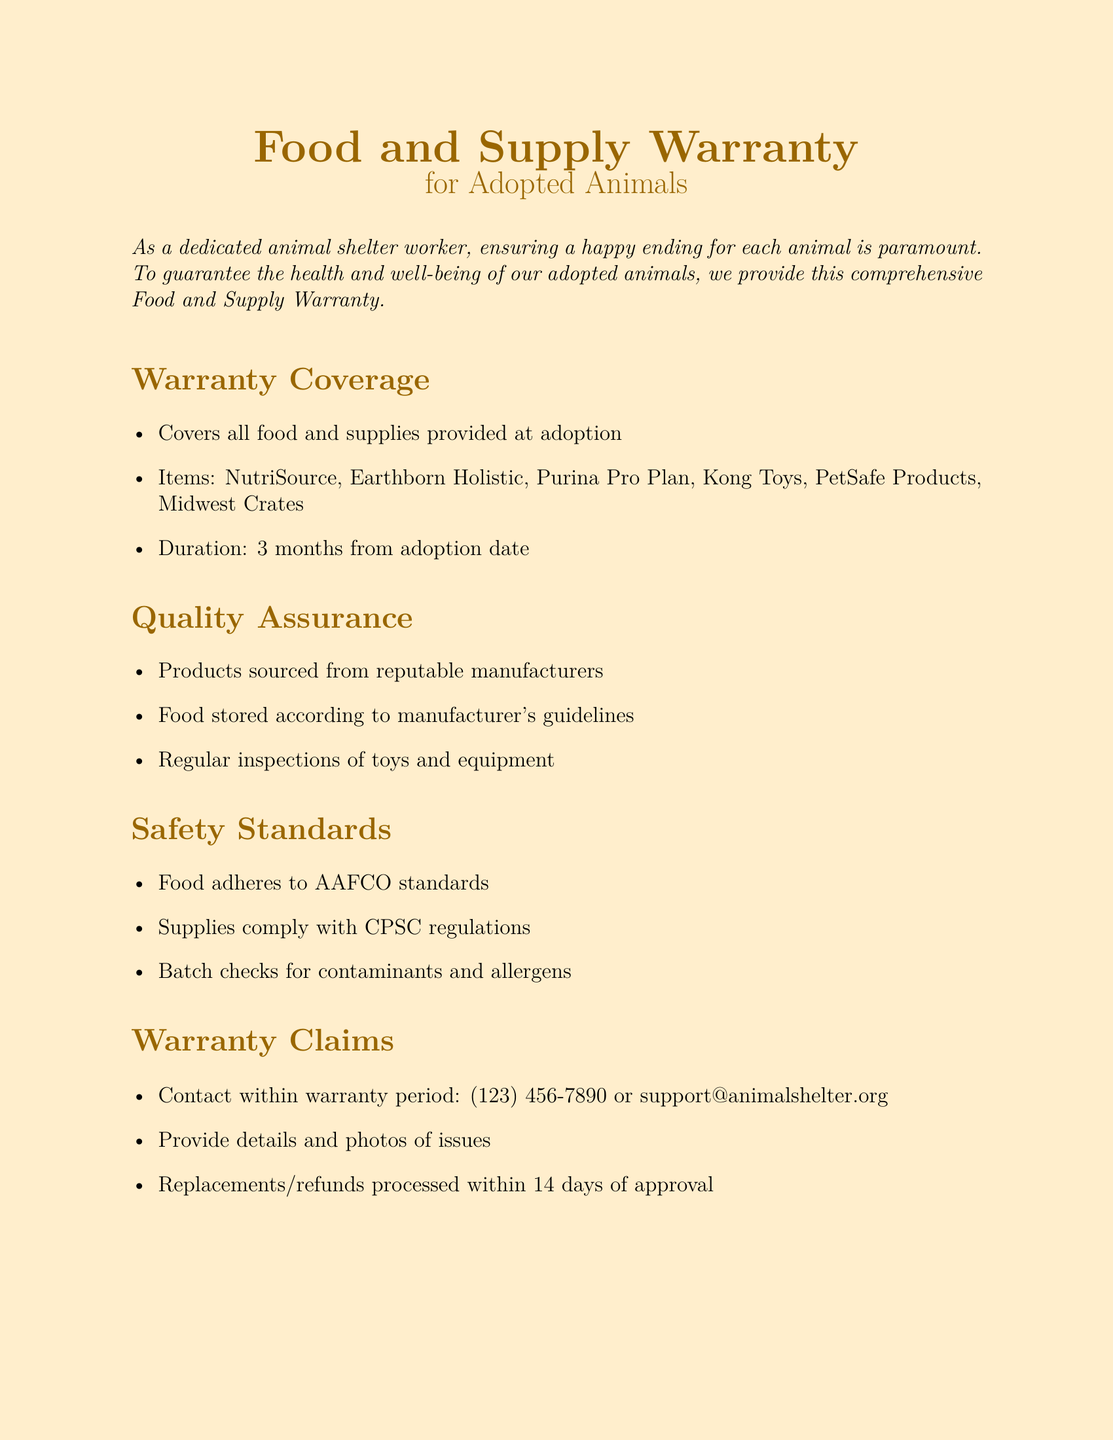What does the warranty cover? The warranty covers all food and supplies provided at adoption.
Answer: All food and supplies provided at adoption Which food brands are included in the warranty? The document lists specific food brands covered under the warranty.
Answer: NutriSource, Earthborn Holistic, Purina Pro Plan What is the duration of the warranty? The document specifies the time period for which the warranty is valid after adoption.
Answer: 3 months from adoption date What safety standards does the food adhere to? The document references specific standards related to food safety.
Answer: AAFCO standards What should a person do to make a warranty claim? The document provides a method to initiate a warranty claim.
Answer: Contact within warranty period: (123) 456-7890 or support@animalshelter.org What is excluded from the warranty coverage? The document mentions specific exclusions that are not covered under the warranty.
Answer: Damages due to misuse, neglect, or improper storage How long does it take to process replacements or refunds? The document indicates the expected time frame for processing warranty claims.
Answer: 14 days of approval What do batch checks ensure? The document explains the purpose of batch checks in relation to product safety.
Answer: Contaminants and allergens 